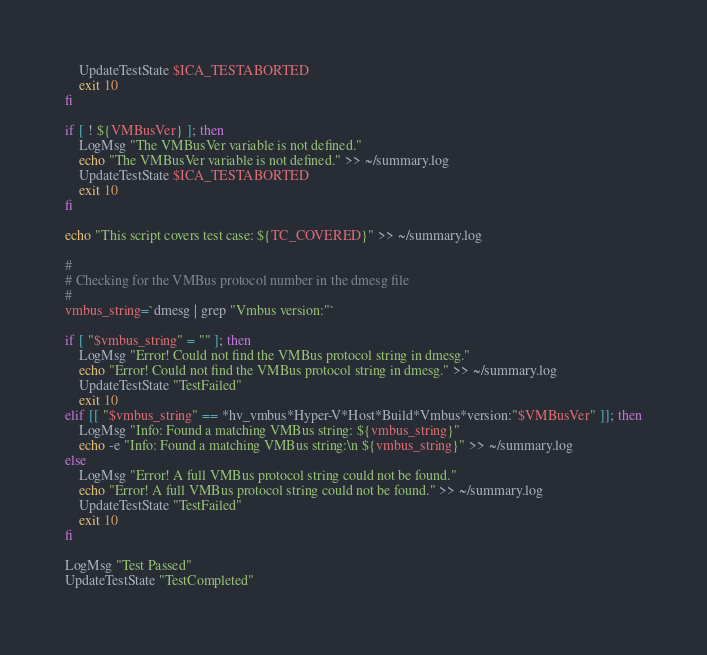Convert code to text. <code><loc_0><loc_0><loc_500><loc_500><_Bash_>    UpdateTestState $ICA_TESTABORTED
    exit 10
fi

if [ ! ${VMBusVer} ]; then
    LogMsg "The VMBusVer variable is not defined."
	echo "The VMBusVer variable is not defined." >> ~/summary.log
    UpdateTestState $ICA_TESTABORTED
    exit 10
fi

echo "This script covers test case: ${TC_COVERED}" >> ~/summary.log

#
# Checking for the VMBus protocol number in the dmesg file
#
vmbus_string=`dmesg | grep "Vmbus version:"`

if [ "$vmbus_string" = "" ]; then
	LogMsg "Error! Could not find the VMBus protocol string in dmesg."
	echo "Error! Could not find the VMBus protocol string in dmesg." >> ~/summary.log
	UpdateTestState "TestFailed"
    exit 10
elif [[ "$vmbus_string" == *hv_vmbus*Hyper-V*Host*Build*Vmbus*version:"$VMBusVer" ]]; then
	LogMsg "Info: Found a matching VMBus string: ${vmbus_string}"
	echo -e "Info: Found a matching VMBus string:\n ${vmbus_string}" >> ~/summary.log
else
	LogMsg "Error! A full VMBus protocol string could not be found."
	echo "Error! A full VMBus protocol string could not be found." >> ~/summary.log
	UpdateTestState "TestFailed"
	exit 10
fi

LogMsg "Test Passed"
UpdateTestState "TestCompleted"
</code> 